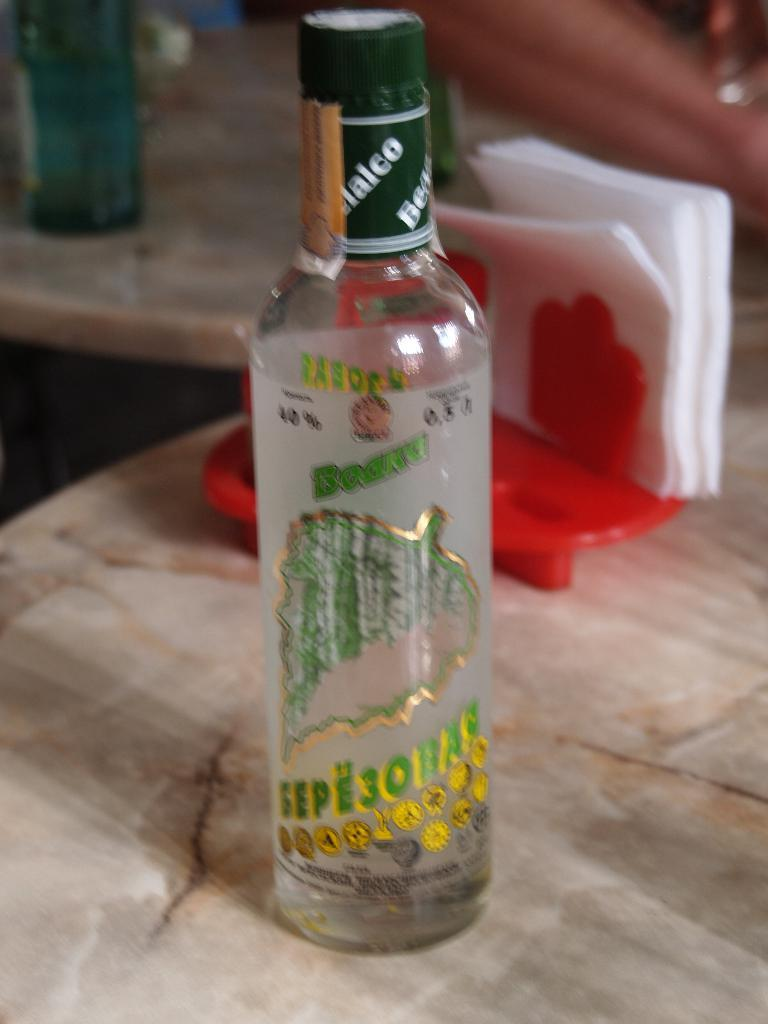What object is on the table in the image? There is a bottle on the table in the image. What color is the bottle? The bottle is green. What other object is on the table in the image? There is a tissue stand on the table in the image. What color is the tissue stand? The tissue stand is red. Is there a gold crow perched on the green bottle in the image? No, there is no crow, gold or otherwise, present in the image. 